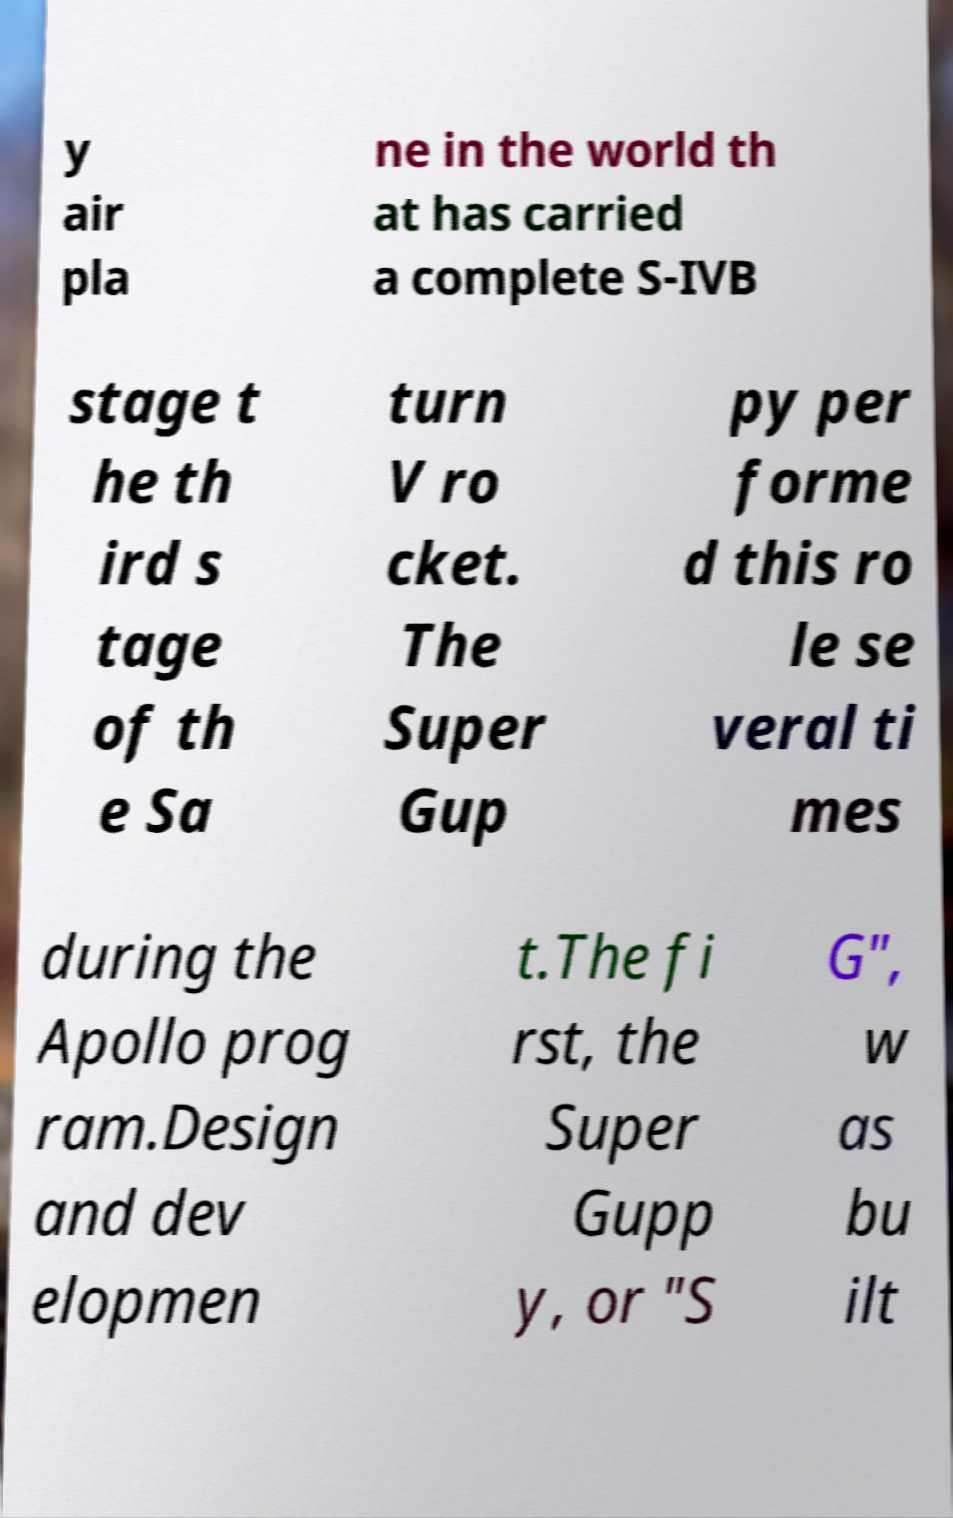Can you read and provide the text displayed in the image?This photo seems to have some interesting text. Can you extract and type it out for me? y air pla ne in the world th at has carried a complete S-IVB stage t he th ird s tage of th e Sa turn V ro cket. The Super Gup py per forme d this ro le se veral ti mes during the Apollo prog ram.Design and dev elopmen t.The fi rst, the Super Gupp y, or "S G", w as bu ilt 